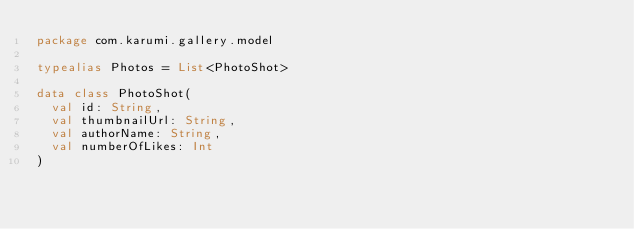<code> <loc_0><loc_0><loc_500><loc_500><_Kotlin_>package com.karumi.gallery.model

typealias Photos = List<PhotoShot>

data class PhotoShot(
  val id: String,
  val thumbnailUrl: String,
  val authorName: String,
  val numberOfLikes: Int
)</code> 